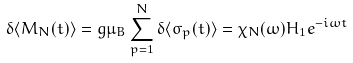Convert formula to latex. <formula><loc_0><loc_0><loc_500><loc_500>\delta \langle M _ { N } ( t ) \rangle = g \mu _ { B } \sum _ { p = 1 } ^ { N } \delta \langle \sigma _ { p } ( t ) \rangle = \chi _ { N } ( \omega ) H _ { 1 } e ^ { - i \omega t }</formula> 